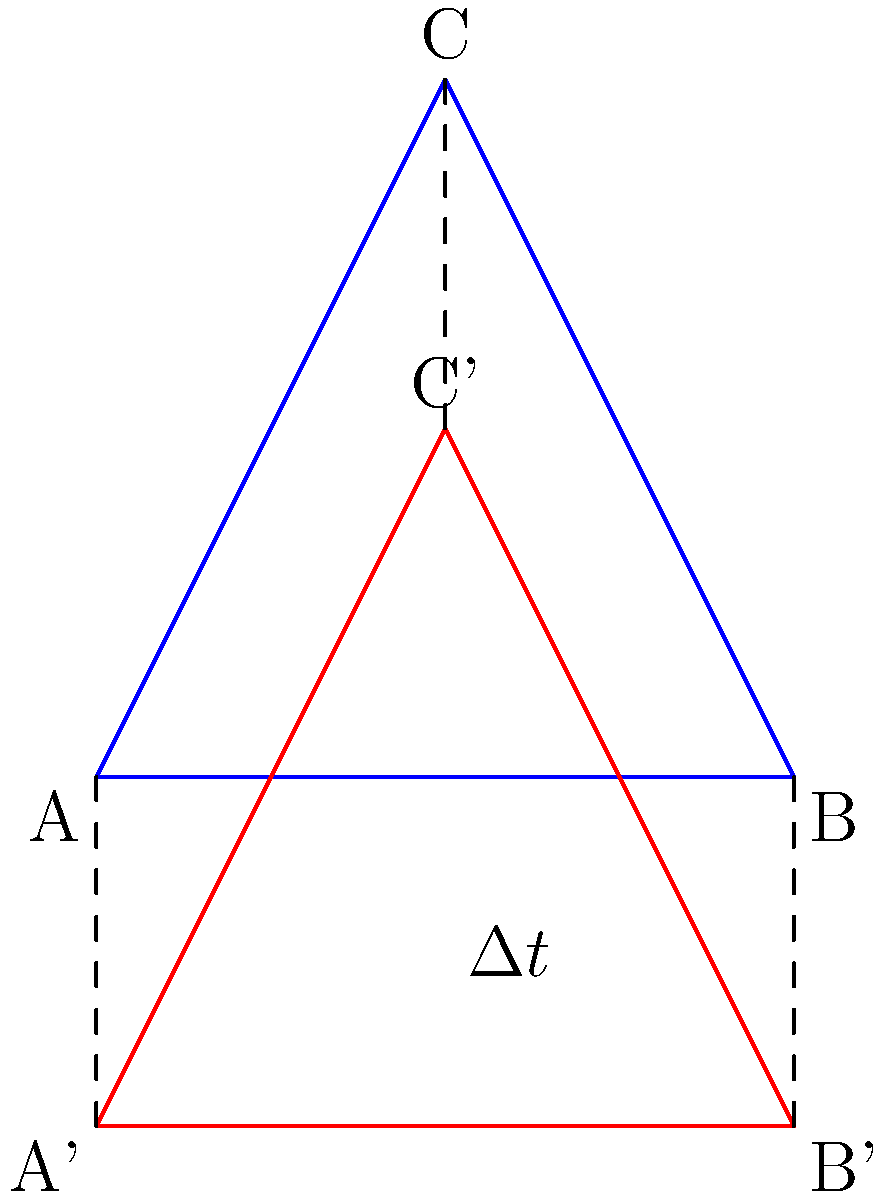Consider two identical triangles ABC and A'B'C' in different reference frames, where A'B'C' is moving at a relativistic speed relative to ABC. If the proper time between events at A and A' is $\Delta \tau$, and the coordinate time in the ABC frame is $\Delta t$, how does the congruence of these triangles relate to time dilation? Express your answer in terms of $\gamma$ (Lorentz factor). To understand how congruence relates to time dilation in this scenario, we need to follow these steps:

1) In special relativity, time dilation is described by the equation:
   $$\Delta t = \gamma \Delta \tau$$
   where $\gamma$ is the Lorentz factor: $\gamma = \frac{1}{\sqrt{1-v^2/c^2}}$

2) The triangle A'B'C' is moving at a relativistic speed relative to ABC. From the perspective of the ABC frame, A'B'C' will appear to be length contracted in the direction of motion.

3) The length contraction is given by:
   $$L = \frac{L_0}{\gamma}$$
   where $L$ is the observed length and $L_0$ is the proper length.

4) This means that in the ABC frame, A'B'C' will appear shorter in the direction of motion by a factor of $\frac{1}{\gamma}$.

5) However, lengths perpendicular to the direction of motion are not affected by relativistic motion.

6) As a result, from the perspective of the ABC frame, A'B'C' will no longer appear congruent to ABC. It will appear contracted in one dimension.

7) The ratio of the contracted dimension to the original dimension is $\frac{1}{\gamma}$.

8) This is the inverse of the time dilation factor, which is $\gamma$.

Therefore, the loss of congruence (represented by the contraction factor $\frac{1}{\gamma}$) is directly related to the time dilation factor $\gamma$.
Answer: $\frac{1}{\gamma}$ 